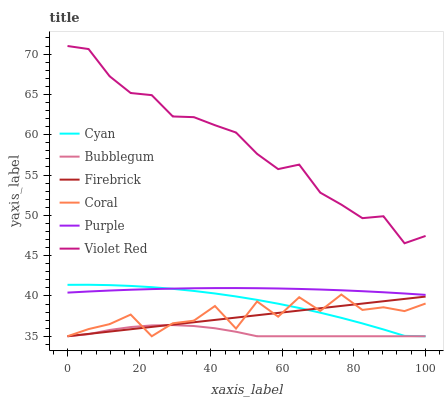Does Bubblegum have the minimum area under the curve?
Answer yes or no. Yes. Does Violet Red have the maximum area under the curve?
Answer yes or no. Yes. Does Purple have the minimum area under the curve?
Answer yes or no. No. Does Purple have the maximum area under the curve?
Answer yes or no. No. Is Firebrick the smoothest?
Answer yes or no. Yes. Is Coral the roughest?
Answer yes or no. Yes. Is Purple the smoothest?
Answer yes or no. No. Is Purple the roughest?
Answer yes or no. No. Does Firebrick have the lowest value?
Answer yes or no. Yes. Does Purple have the lowest value?
Answer yes or no. No. Does Violet Red have the highest value?
Answer yes or no. Yes. Does Purple have the highest value?
Answer yes or no. No. Is Firebrick less than Purple?
Answer yes or no. Yes. Is Purple greater than Firebrick?
Answer yes or no. Yes. Does Bubblegum intersect Firebrick?
Answer yes or no. Yes. Is Bubblegum less than Firebrick?
Answer yes or no. No. Is Bubblegum greater than Firebrick?
Answer yes or no. No. Does Firebrick intersect Purple?
Answer yes or no. No. 